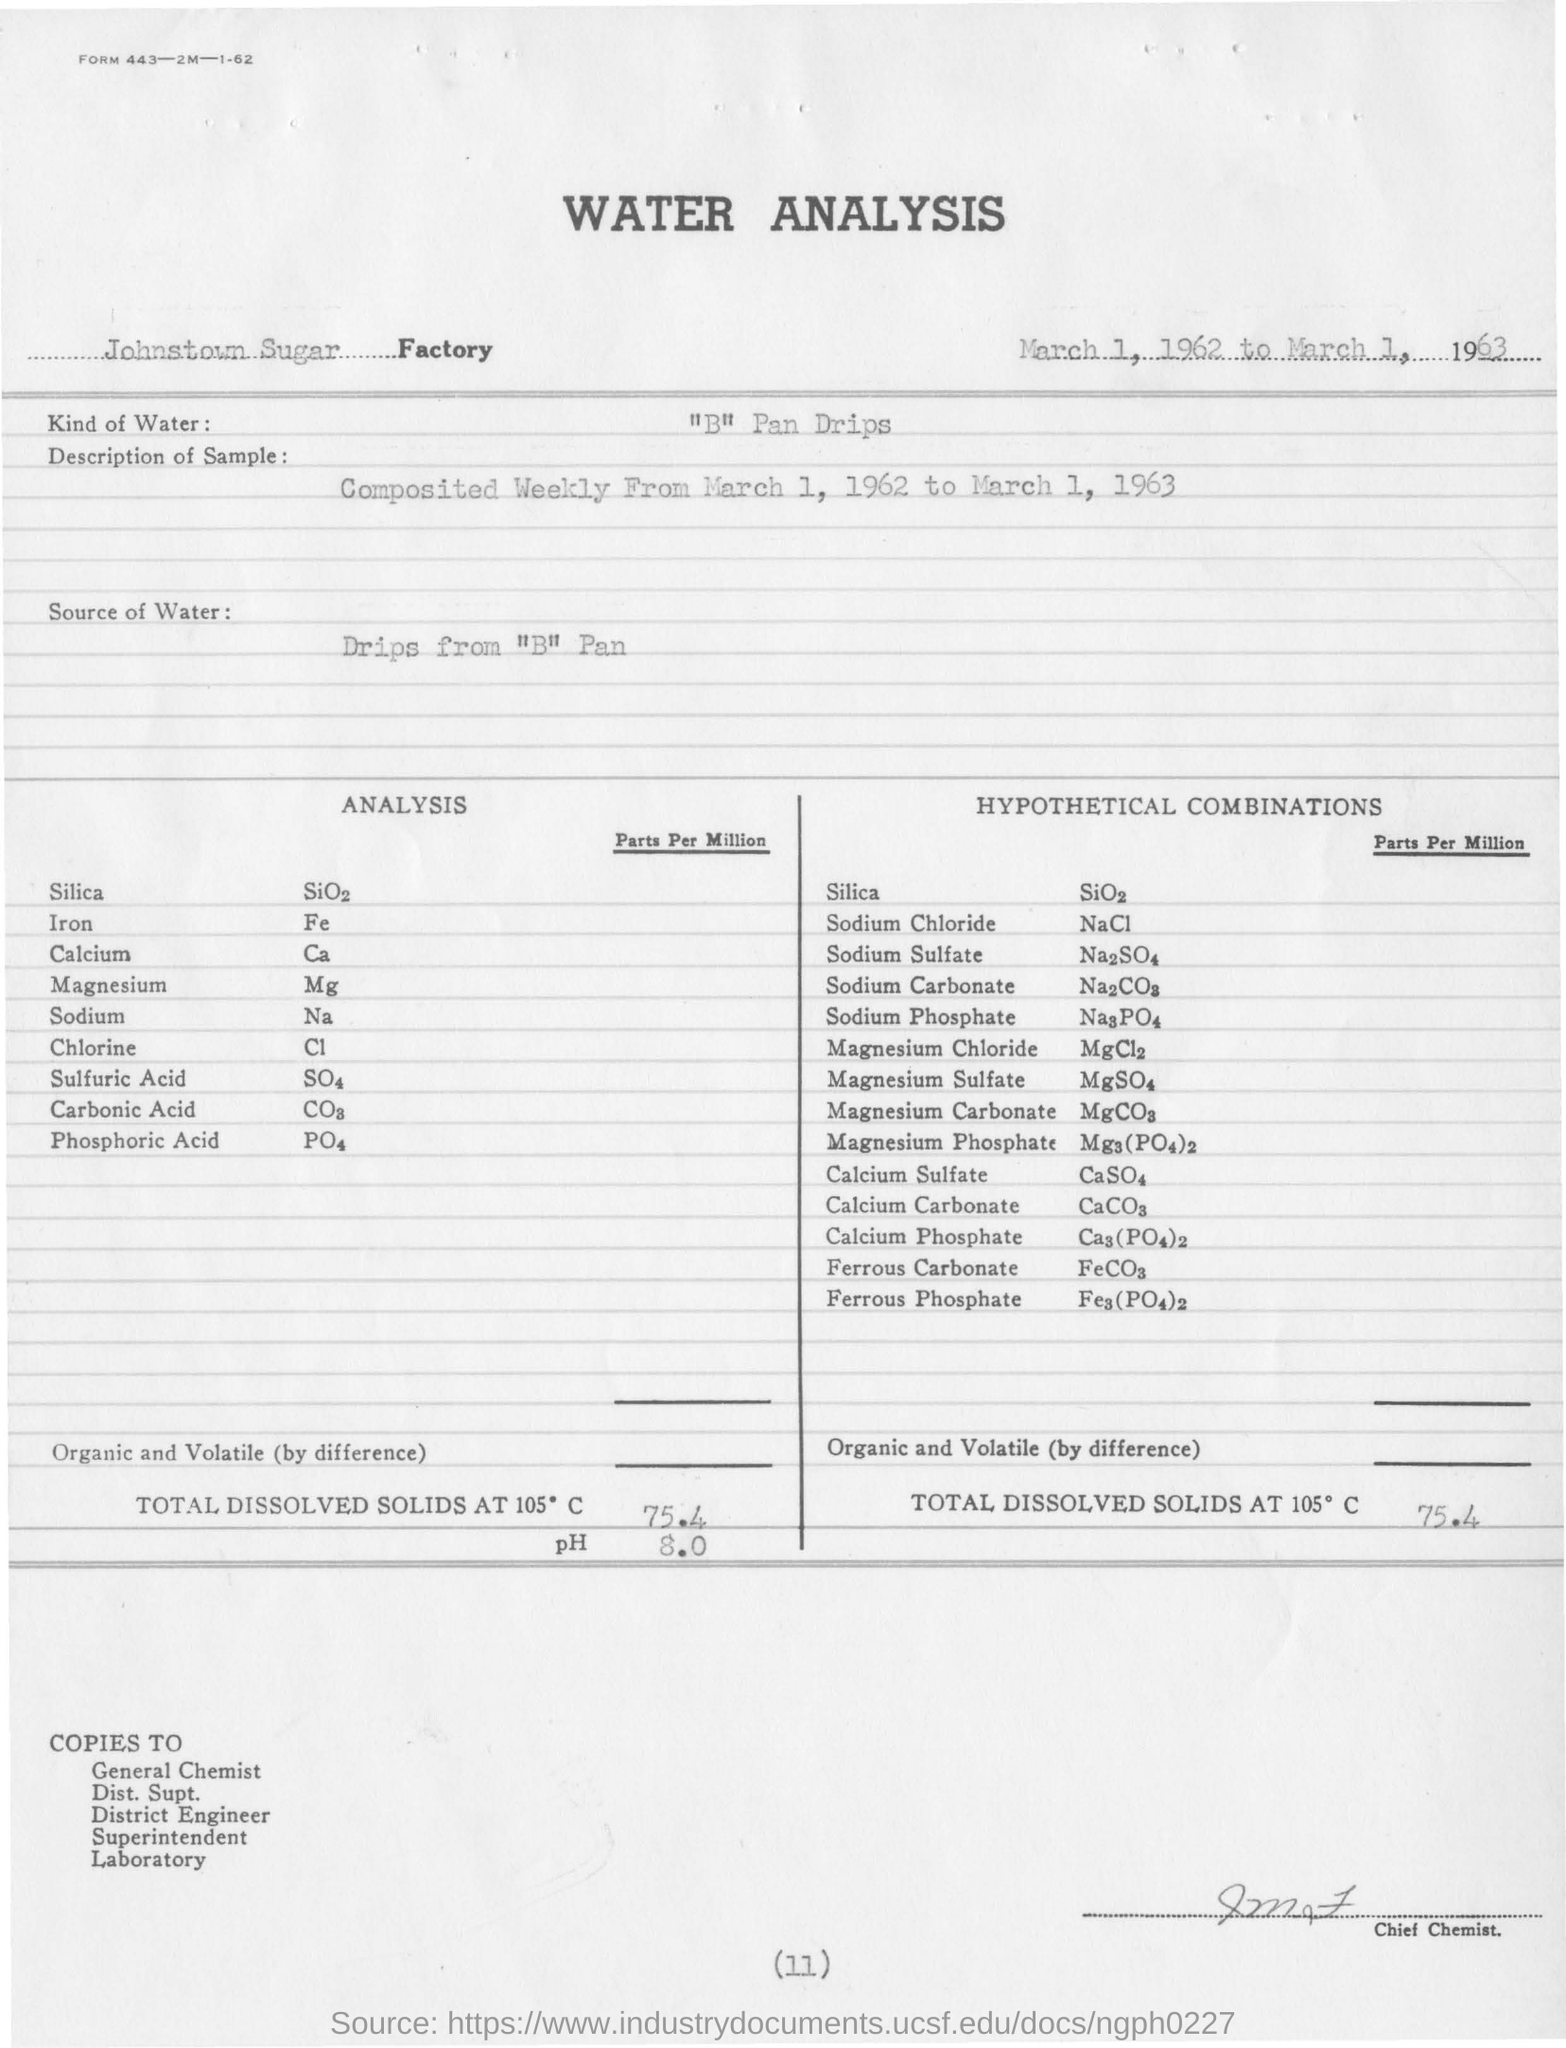In which factory the water analysis is conducted ?
Give a very brief answer. Johnstown Sugar Factory. What kind of water is used in water analysis ?
Provide a succinct answer. "B" Pan Drips. What is the amount of total dissolved solids at 105 degrees c ?
Provide a succinct answer. 75.4. What is the value of ph obtained in the water analysis?
Offer a terse response. 8.0. What does fe denotes in the given analysis ?
Your response must be concise. Iron. 